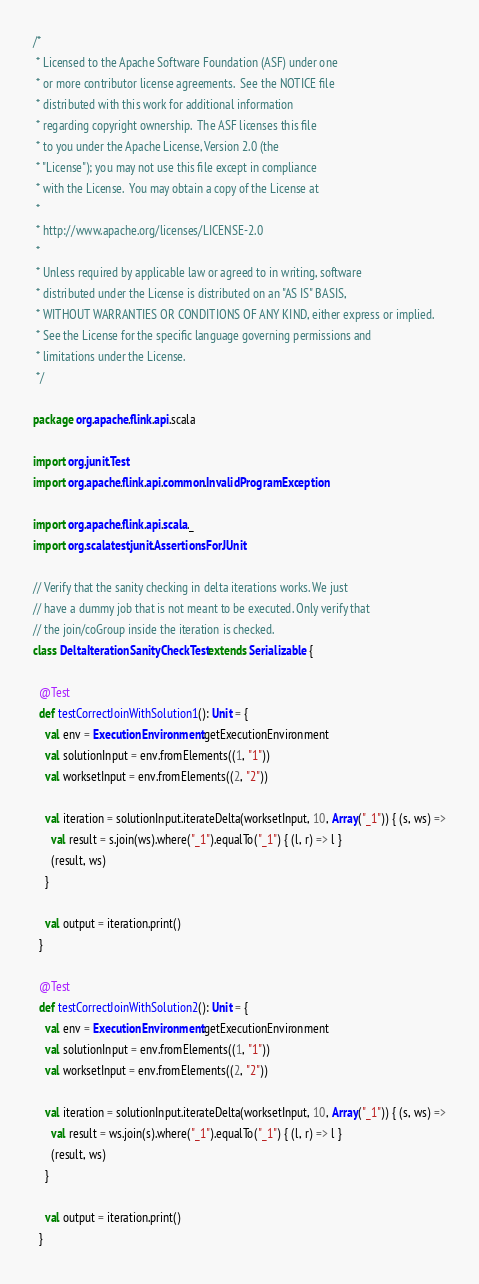<code> <loc_0><loc_0><loc_500><loc_500><_Scala_>/*
 * Licensed to the Apache Software Foundation (ASF) under one
 * or more contributor license agreements.  See the NOTICE file
 * distributed with this work for additional information
 * regarding copyright ownership.  The ASF licenses this file
 * to you under the Apache License, Version 2.0 (the
 * "License"); you may not use this file except in compliance
 * with the License.  You may obtain a copy of the License at
 *
 * http://www.apache.org/licenses/LICENSE-2.0
 *
 * Unless required by applicable law or agreed to in writing, software
 * distributed under the License is distributed on an "AS IS" BASIS,
 * WITHOUT WARRANTIES OR CONDITIONS OF ANY KIND, either express or implied.
 * See the License for the specific language governing permissions and
 * limitations under the License.
 */

package org.apache.flink.api.scala

import org.junit.Test
import org.apache.flink.api.common.InvalidProgramException

import org.apache.flink.api.scala._
import org.scalatest.junit.AssertionsForJUnit

// Verify that the sanity checking in delta iterations works. We just
// have a dummy job that is not meant to be executed. Only verify that
// the join/coGroup inside the iteration is checked.
class DeltaIterationSanityCheckTest extends Serializable {

  @Test
  def testCorrectJoinWithSolution1(): Unit = {
    val env = ExecutionEnvironment.getExecutionEnvironment
    val solutionInput = env.fromElements((1, "1"))
    val worksetInput = env.fromElements((2, "2"))

    val iteration = solutionInput.iterateDelta(worksetInput, 10, Array("_1")) { (s, ws) =>
      val result = s.join(ws).where("_1").equalTo("_1") { (l, r) => l }
      (result, ws)
    }

    val output = iteration.print()
  }

  @Test
  def testCorrectJoinWithSolution2(): Unit = {
    val env = ExecutionEnvironment.getExecutionEnvironment
    val solutionInput = env.fromElements((1, "1"))
    val worksetInput = env.fromElements((2, "2"))

    val iteration = solutionInput.iterateDelta(worksetInput, 10, Array("_1")) { (s, ws) =>
      val result = ws.join(s).where("_1").equalTo("_1") { (l, r) => l }
      (result, ws)
    }

    val output = iteration.print()
  }
</code> 